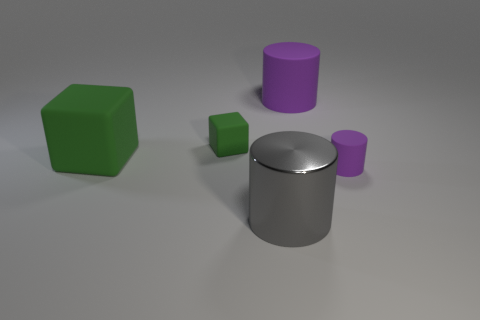Add 5 big green cubes. How many objects exist? 10 Subtract all cylinders. How many objects are left? 2 Subtract all big gray things. Subtract all purple matte cylinders. How many objects are left? 2 Add 5 small matte cylinders. How many small matte cylinders are left? 6 Add 1 green rubber cylinders. How many green rubber cylinders exist? 1 Subtract 0 blue cylinders. How many objects are left? 5 